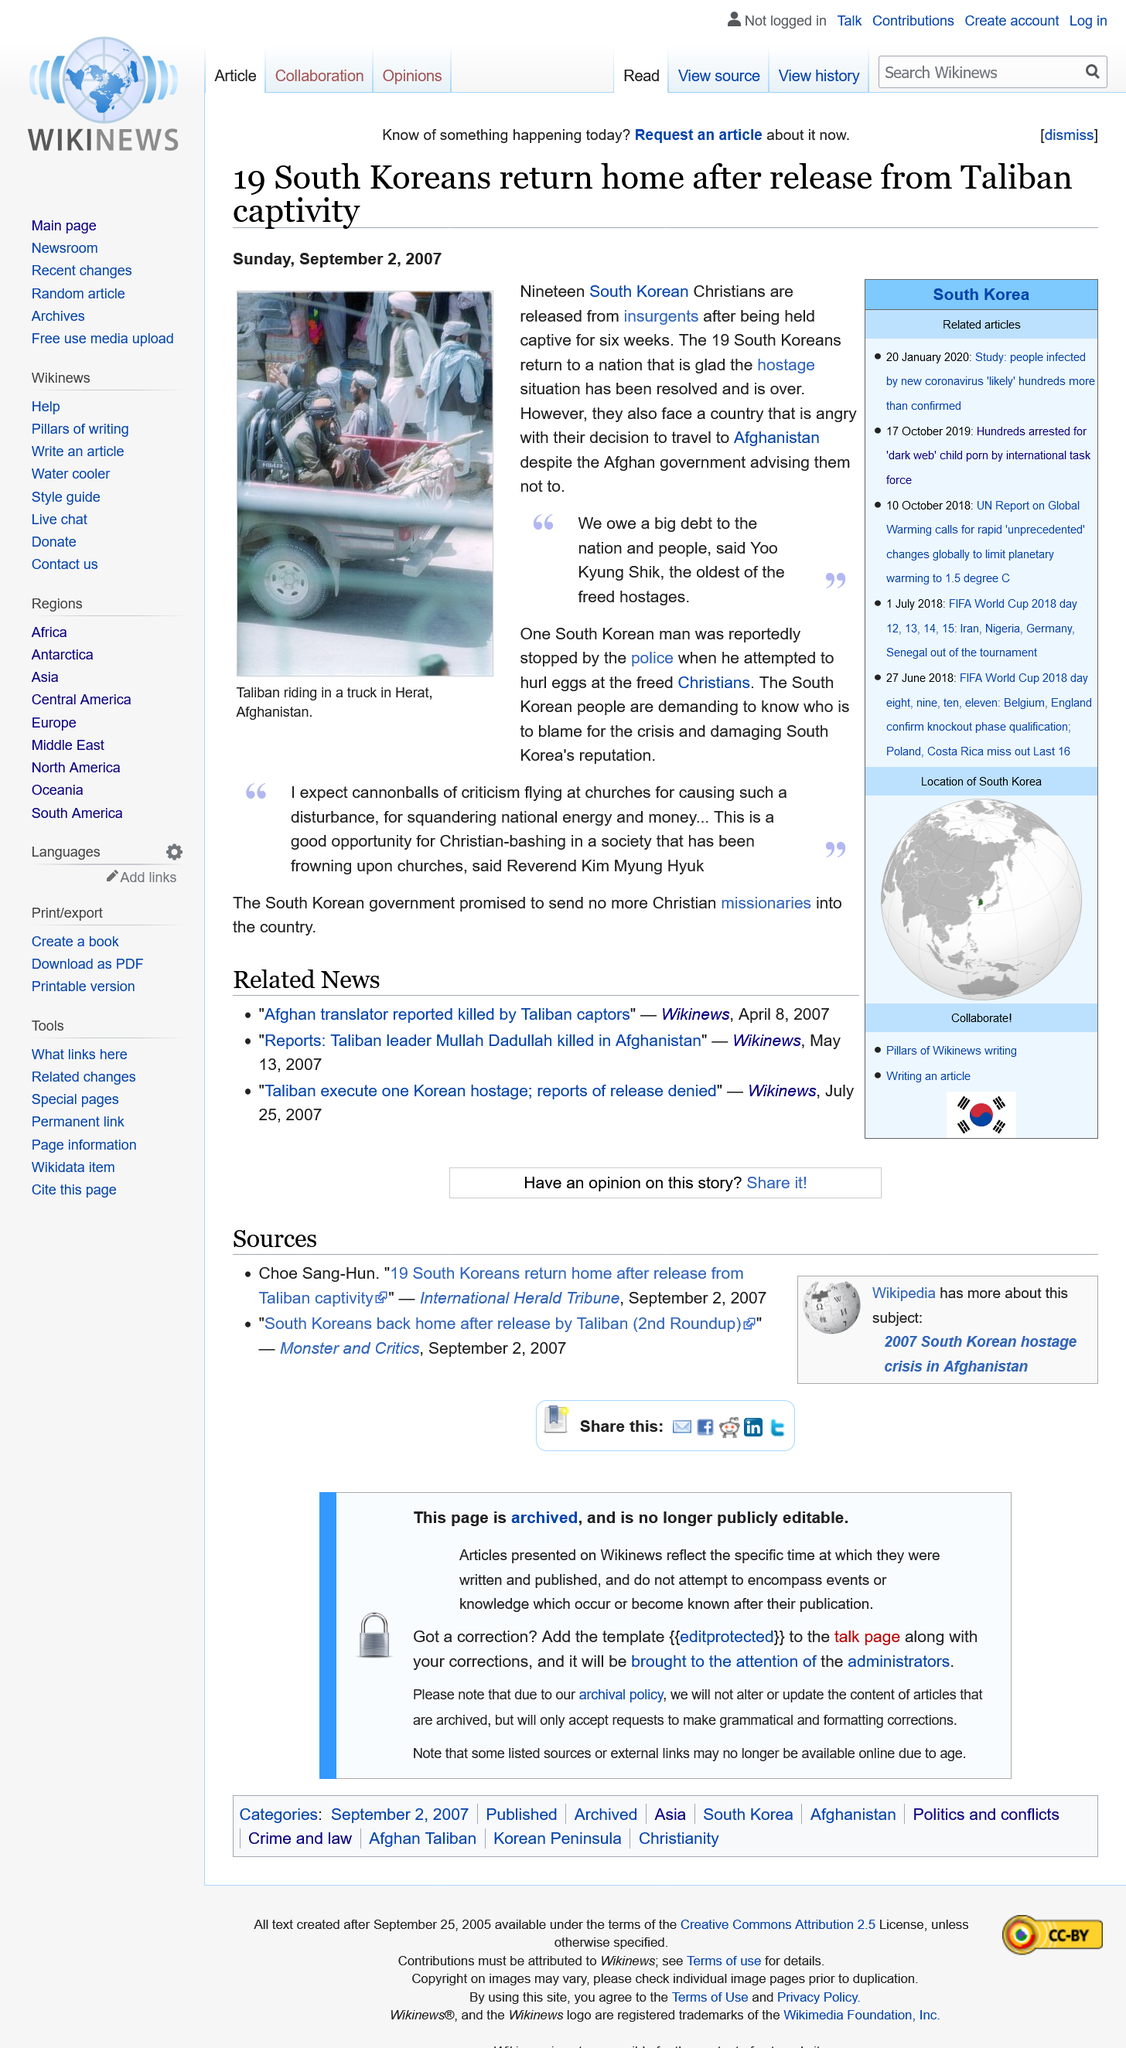Identify some key points in this picture. The South Korean hostages were held captive for a period of six weeks. According to reports, 19 South Korean Christians were recently released by the insurgents. The article was written on Sunday, September 2, 2007. 